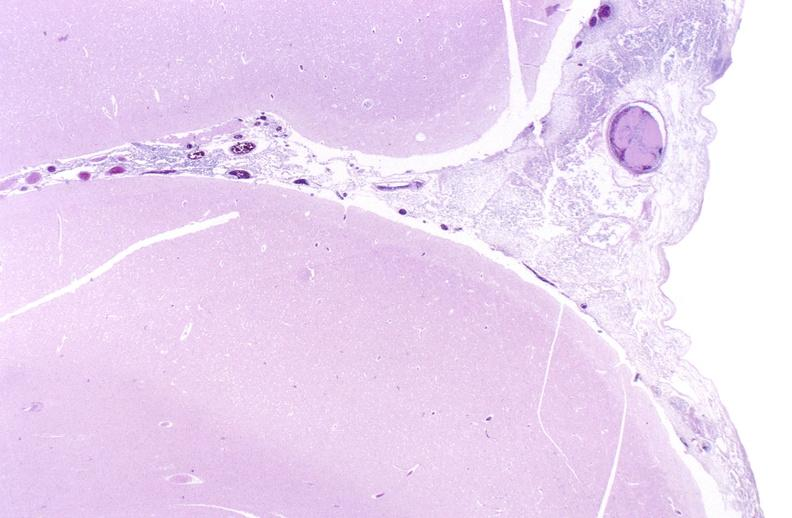does lesion show bacterial meningitis?
Answer the question using a single word or phrase. No 